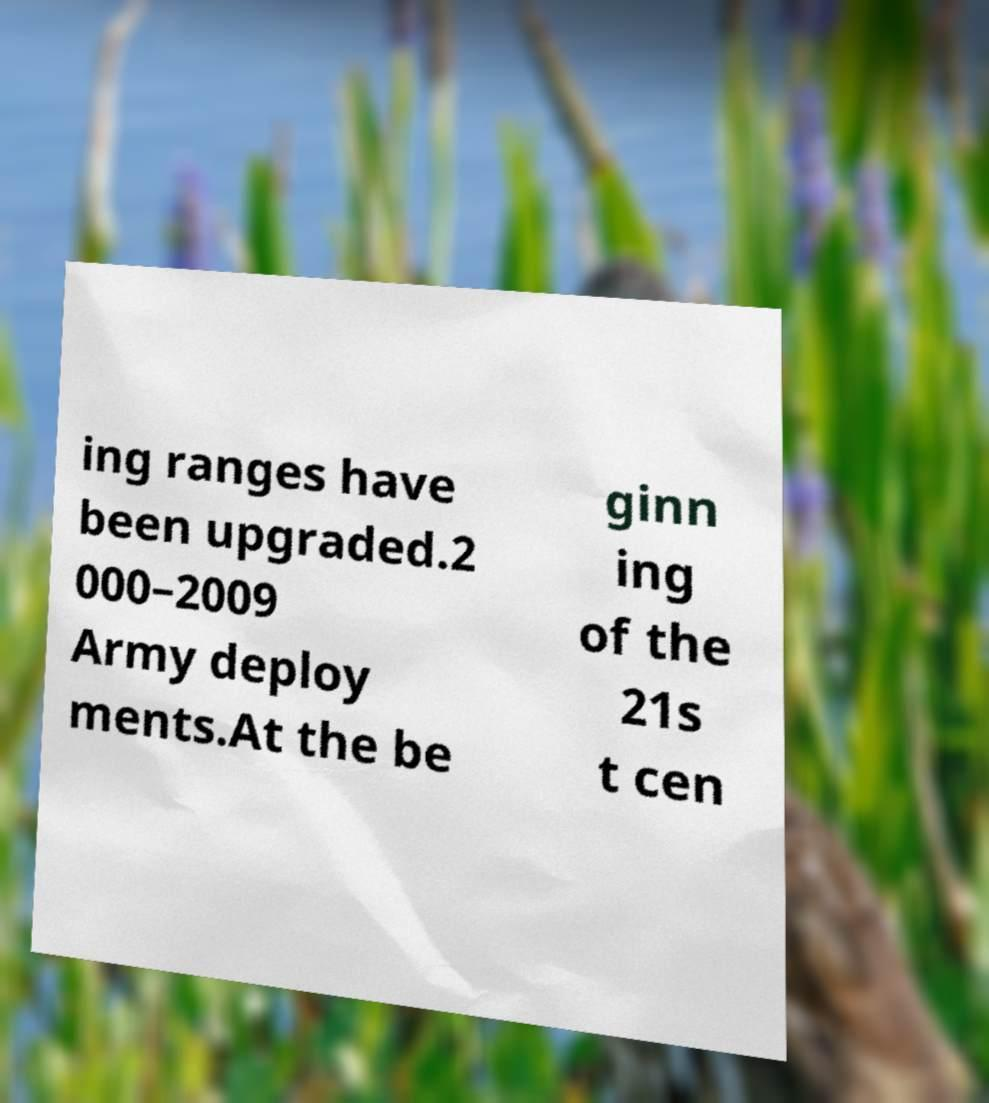Please identify and transcribe the text found in this image. ing ranges have been upgraded.2 000–2009 Army deploy ments.At the be ginn ing of the 21s t cen 